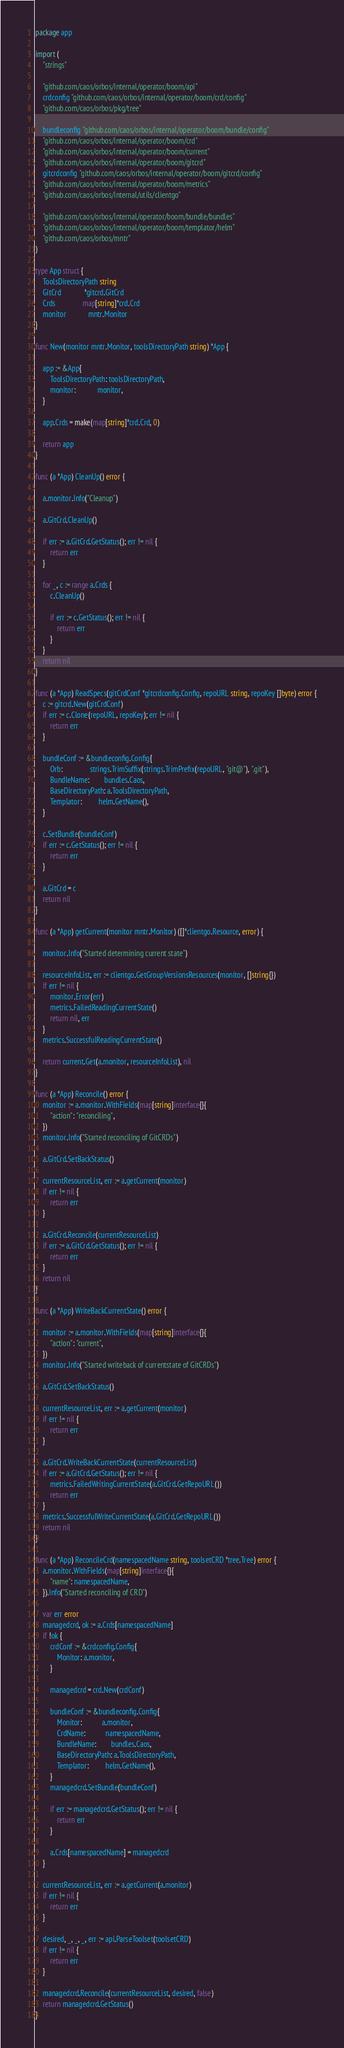<code> <loc_0><loc_0><loc_500><loc_500><_Go_>package app

import (
	"strings"

	"github.com/caos/orbos/internal/operator/boom/api"
	crdconfig "github.com/caos/orbos/internal/operator/boom/crd/config"
	"github.com/caos/orbos/pkg/tree"

	bundleconfig "github.com/caos/orbos/internal/operator/boom/bundle/config"
	"github.com/caos/orbos/internal/operator/boom/crd"
	"github.com/caos/orbos/internal/operator/boom/current"
	"github.com/caos/orbos/internal/operator/boom/gitcrd"
	gitcrdconfig "github.com/caos/orbos/internal/operator/boom/gitcrd/config"
	"github.com/caos/orbos/internal/operator/boom/metrics"
	"github.com/caos/orbos/internal/utils/clientgo"

	"github.com/caos/orbos/internal/operator/boom/bundle/bundles"
	"github.com/caos/orbos/internal/operator/boom/templator/helm"
	"github.com/caos/orbos/mntr"
)

type App struct {
	ToolsDirectoryPath string
	GitCrd             *gitcrd.GitCrd
	Crds               map[string]*crd.Crd
	monitor            mntr.Monitor
}

func New(monitor mntr.Monitor, toolsDirectoryPath string) *App {

	app := &App{
		ToolsDirectoryPath: toolsDirectoryPath,
		monitor:            monitor,
	}

	app.Crds = make(map[string]*crd.Crd, 0)

	return app
}

func (a *App) CleanUp() error {

	a.monitor.Info("Cleanup")

	a.GitCrd.CleanUp()

	if err := a.GitCrd.GetStatus(); err != nil {
		return err
	}

	for _, c := range a.Crds {
		c.CleanUp()

		if err := c.GetStatus(); err != nil {
			return err
		}
	}
	return nil
}

func (a *App) ReadSpecs(gitCrdConf *gitcrdconfig.Config, repoURL string, repoKey []byte) error {
	c := gitcrd.New(gitCrdConf)
	if err := c.Clone(repoURL, repoKey); err != nil {
		return err
	}

	bundleConf := &bundleconfig.Config{
		Orb:               strings.TrimSuffix(strings.TrimPrefix(repoURL, "git@"), ".git"),
		BundleName:        bundles.Caos,
		BaseDirectoryPath: a.ToolsDirectoryPath,
		Templator:         helm.GetName(),
	}

	c.SetBundle(bundleConf)
	if err := c.GetStatus(); err != nil {
		return err
	}

	a.GitCrd = c
	return nil
}

func (a *App) getCurrent(monitor mntr.Monitor) ([]*clientgo.Resource, error) {

	monitor.Info("Started determining current state")

	resourceInfoList, err := clientgo.GetGroupVersionsResources(monitor, []string{})
	if err != nil {
		monitor.Error(err)
		metrics.FailedReadingCurrentState()
		return nil, err
	}
	metrics.SuccessfulReadingCurrentState()

	return current.Get(a.monitor, resourceInfoList), nil
}

func (a *App) Reconcile() error {
	monitor := a.monitor.WithFields(map[string]interface{}{
		"action": "reconciling",
	})
	monitor.Info("Started reconciling of GitCRDs")

	a.GitCrd.SetBackStatus()

	currentResourceList, err := a.getCurrent(monitor)
	if err != nil {
		return err
	}

	a.GitCrd.Reconcile(currentResourceList)
	if err := a.GitCrd.GetStatus(); err != nil {
		return err
	}
	return nil
}

func (a *App) WriteBackCurrentState() error {

	monitor := a.monitor.WithFields(map[string]interface{}{
		"action": "current",
	})
	monitor.Info("Started writeback of currentstate of GitCRDs")

	a.GitCrd.SetBackStatus()

	currentResourceList, err := a.getCurrent(monitor)
	if err != nil {
		return err
	}

	a.GitCrd.WriteBackCurrentState(currentResourceList)
	if err := a.GitCrd.GetStatus(); err != nil {
		metrics.FailedWritingCurrentState(a.GitCrd.GetRepoURL())
		return err
	}
	metrics.SuccessfulWriteCurrentState(a.GitCrd.GetRepoURL())
	return nil
}

func (a *App) ReconcileCrd(namespacedName string, toolsetCRD *tree.Tree) error {
	a.monitor.WithFields(map[string]interface{}{
		"name": namespacedName,
	}).Info("Started reconciling of CRD")

	var err error
	managedcrd, ok := a.Crds[namespacedName]
	if !ok {
		crdConf := &crdconfig.Config{
			Monitor: a.monitor,
		}

		managedcrd = crd.New(crdConf)

		bundleConf := &bundleconfig.Config{
			Monitor:           a.monitor,
			CrdName:           namespacedName,
			BundleName:        bundles.Caos,
			BaseDirectoryPath: a.ToolsDirectoryPath,
			Templator:         helm.GetName(),
		}
		managedcrd.SetBundle(bundleConf)

		if err := managedcrd.GetStatus(); err != nil {
			return err
		}

		a.Crds[namespacedName] = managedcrd
	}

	currentResourceList, err := a.getCurrent(a.monitor)
	if err != nil {
		return err
	}

	desired, _, _, _, err := api.ParseToolset(toolsetCRD)
	if err != nil {
		return err
	}

	managedcrd.Reconcile(currentResourceList, desired, false)
	return managedcrd.GetStatus()
}
</code> 